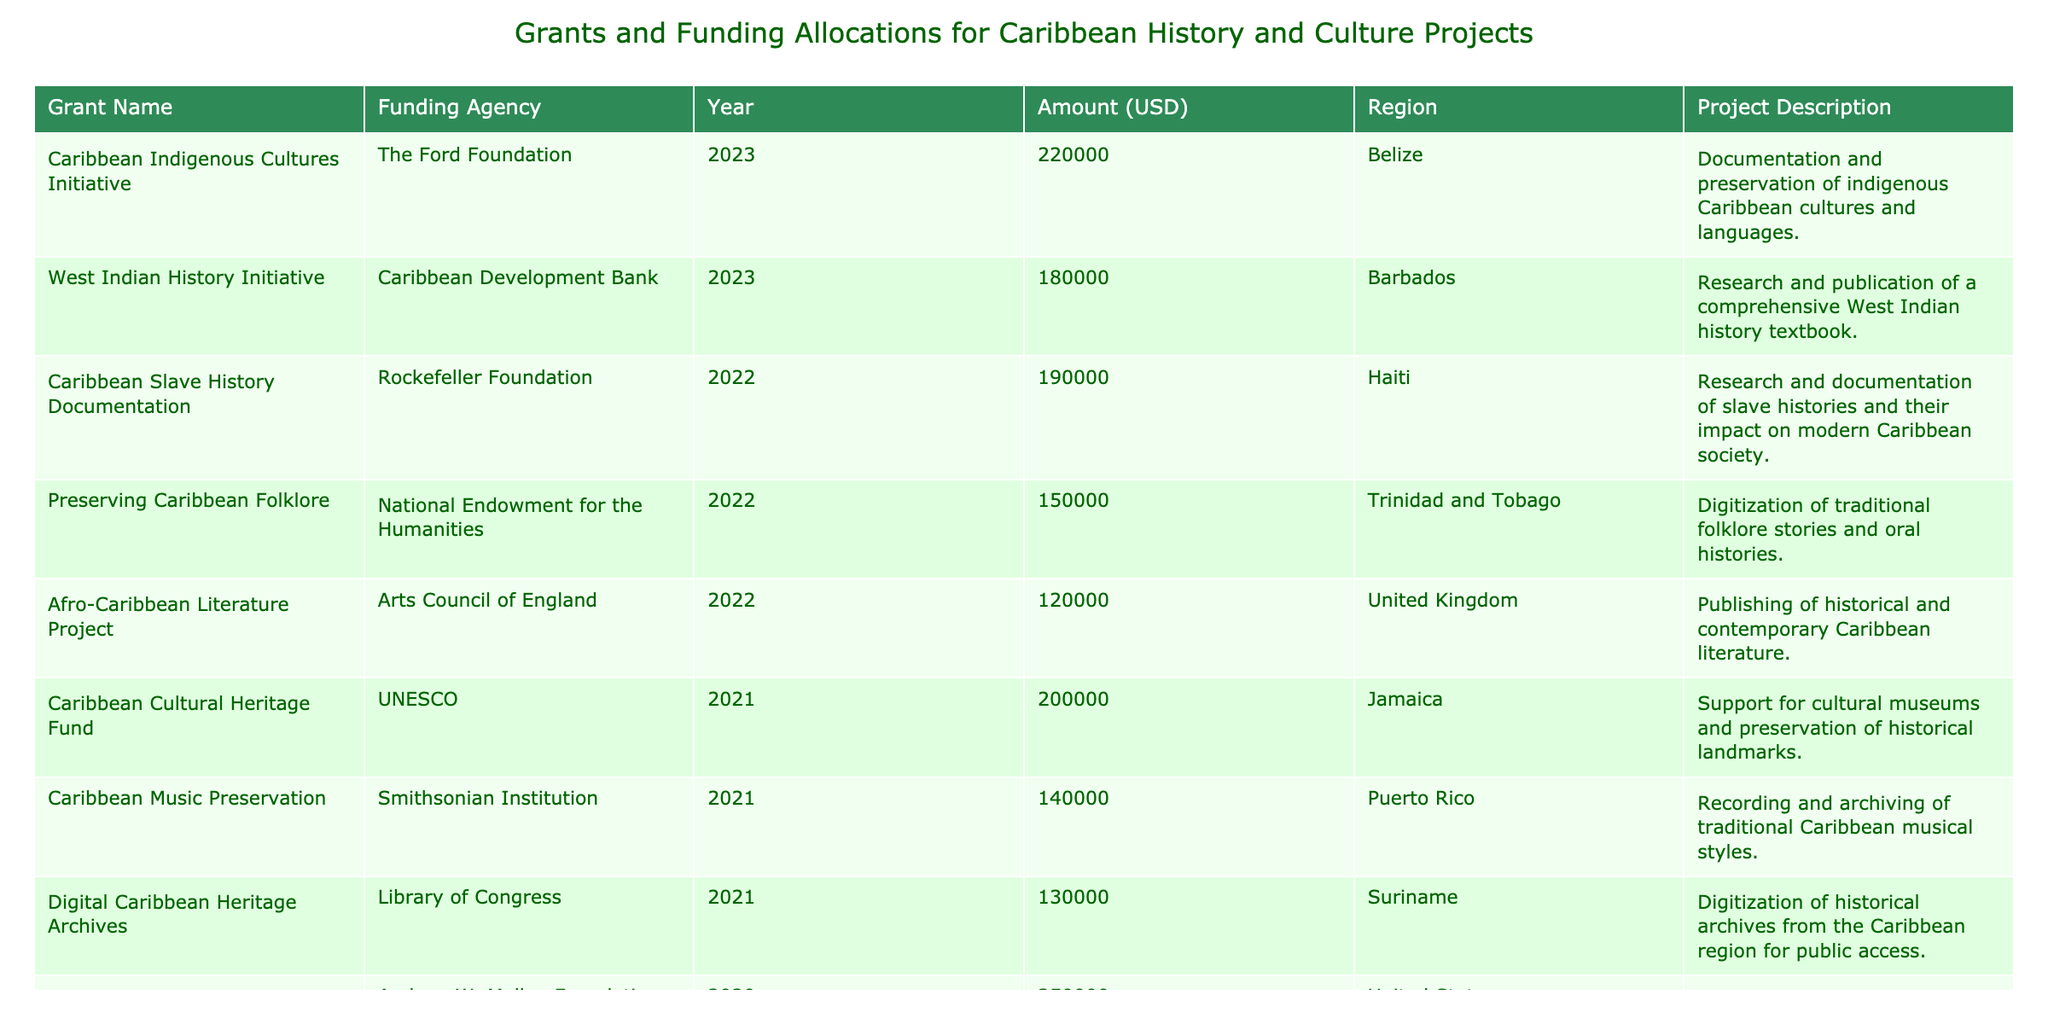What is the total funding amount allocated for projects in the year 2021? In the table, the funding amounts for projects in 2021 are as follows: 200,000 (Caribbean Cultural Heritage Fund), 140,000 (Caribbean Music Preservation), and 130,000 (Digital Caribbean Heritage Archives). Adding these amounts together gives 200,000 + 140,000 + 130,000 = 470,000.
Answer: 470,000 Which project received the highest amount of funding? Looking at the amounts in the 'Amount (USD)' column, Caribbean Diaspora Documentation received 250,000, which is higher than any other funding amounts in the table.
Answer: Caribbean Diaspora Documentation How many projects were funded in 2022? The projects funded in 2022 are: Preserving Caribbean Folklore, Afro-Caribbean Literature Project, and Caribbean Slave History Documentation. This gives a total of 3 projects in the year 2022.
Answer: 3 Is the West Indian History Initiative the only project funded by the Caribbean Development Bank? The table lists the West Indian History Initiative funded by the Caribbean Development Bank, with no other projects mentioned under that funding agency. Thus, it is the only project listed from that agency.
Answer: Yes What is the average funding amount for projects in Trinidad and Tobago? The only project from Trinidad and Tobago is Preserving Caribbean Folklore, which received 150,000. Since this is the only project, the average is simply 150,000.
Answer: 150,000 Compare the funding amounts of projects in the United States versus those in the Caribbean. Projects from the United States received 250,000 for the Caribbean Diaspora Documentation. In contrast, the Caribbean projects include various amounts (e.g., 150,000, 200,000, etc.). The total for Caribbean projects is 150,000 + 200,000 + 180,000 + 190,000 + 140,000 + 220,000 + 160,000 + 130,000 + 140,000 = 1,510,000. Comparing this with the U.S. project amount, we have 250,000 for the U.S. versus 1,510,000 for the Caribbean.
Answer: Caribbean projects received significantly more funding Which region has the second-highest total funding allocation among the projects listed? First, we will calculate the total funding for each region: Trinidad and Tobago (150,000), Jamaica (200,000), Barbados (180,000), United States (250,000), United Kingdom (120,000), Puerto Rico (140,000), Guyana (175,000), Belize (220,000), St. Lucia (160,000), Suriname (130,000), Haiti (190,000), and Bahamas (140,000). Adding these gives the totals per region. The highest is United States (250,000), and the next highest is Belize (220,000). Thus, Belize has the second-highest total funding allocation.
Answer: Belize What percentage of the total funding ($1,660,000) was allocated to the Caribbean Indigenous Cultures Initiative? First, we note that the funding for the Caribbean Indigenous Cultures Initiative is 220,000. To find the percentage, we calculate (220,000 / 1,660,000) * 100, which gives approximately 13.25%.
Answer: 13.25% 